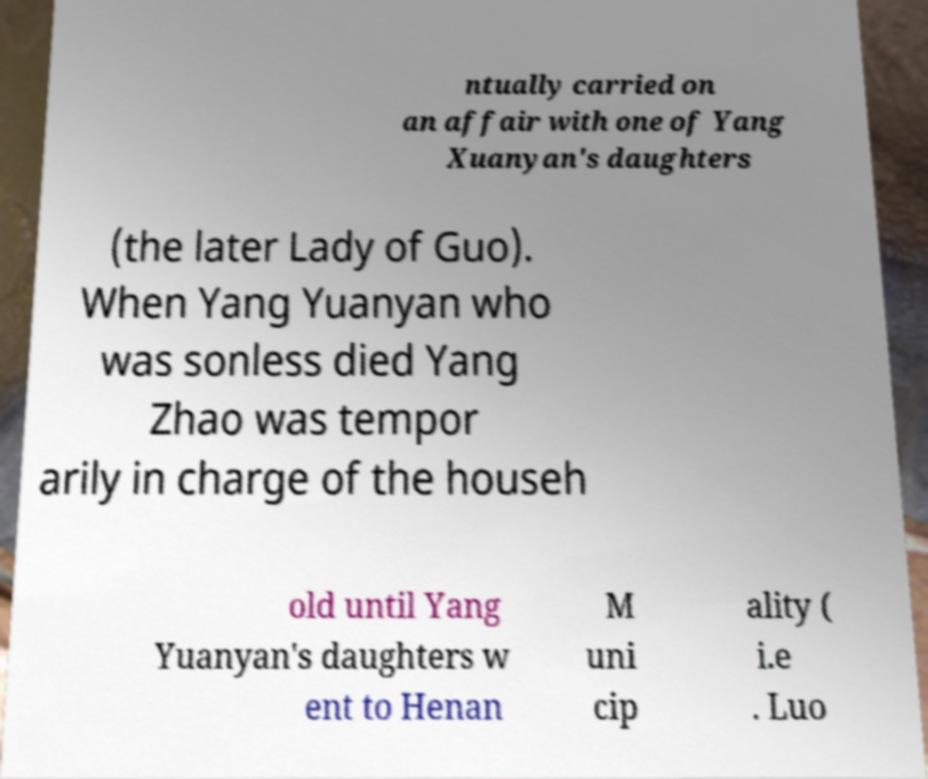Could you assist in decoding the text presented in this image and type it out clearly? ntually carried on an affair with one of Yang Xuanyan's daughters (the later Lady of Guo). When Yang Yuanyan who was sonless died Yang Zhao was tempor arily in charge of the househ old until Yang Yuanyan's daughters w ent to Henan M uni cip ality ( i.e . Luo 